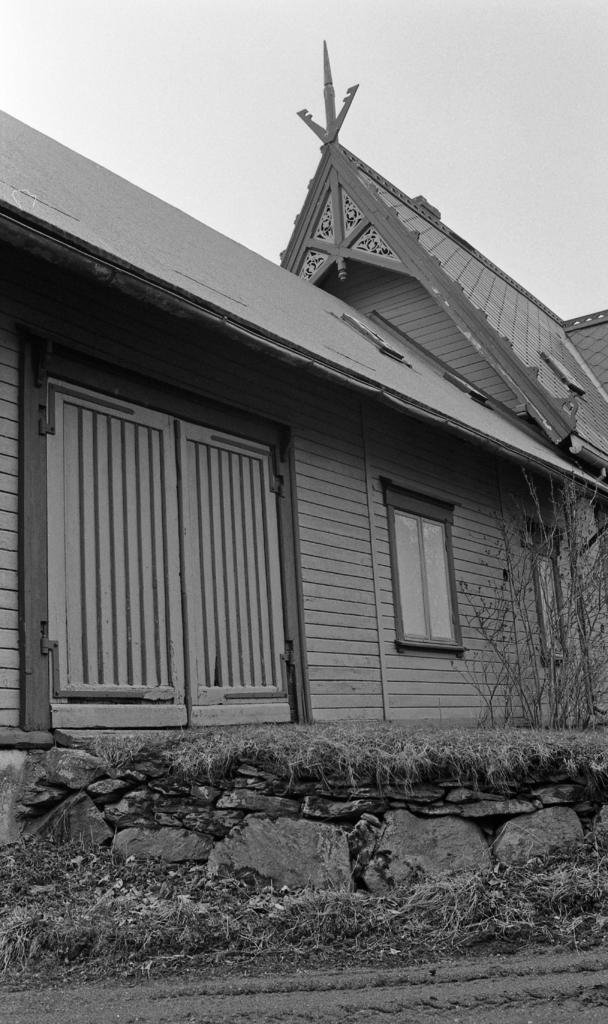What is the color scheme of the image? The image is black and white. What structure can be seen in the image? There is a house in the image. What features does the house have? The house has a window and a door. What type of natural elements are present in the image? There are rocks and a plant with branches in the image. What type of jelly can be seen on the window of the house in the image? There is no jelly present on the window of the house in the image. What subject is being taught in the image? There is no teaching or lesson being depicted in the image. 